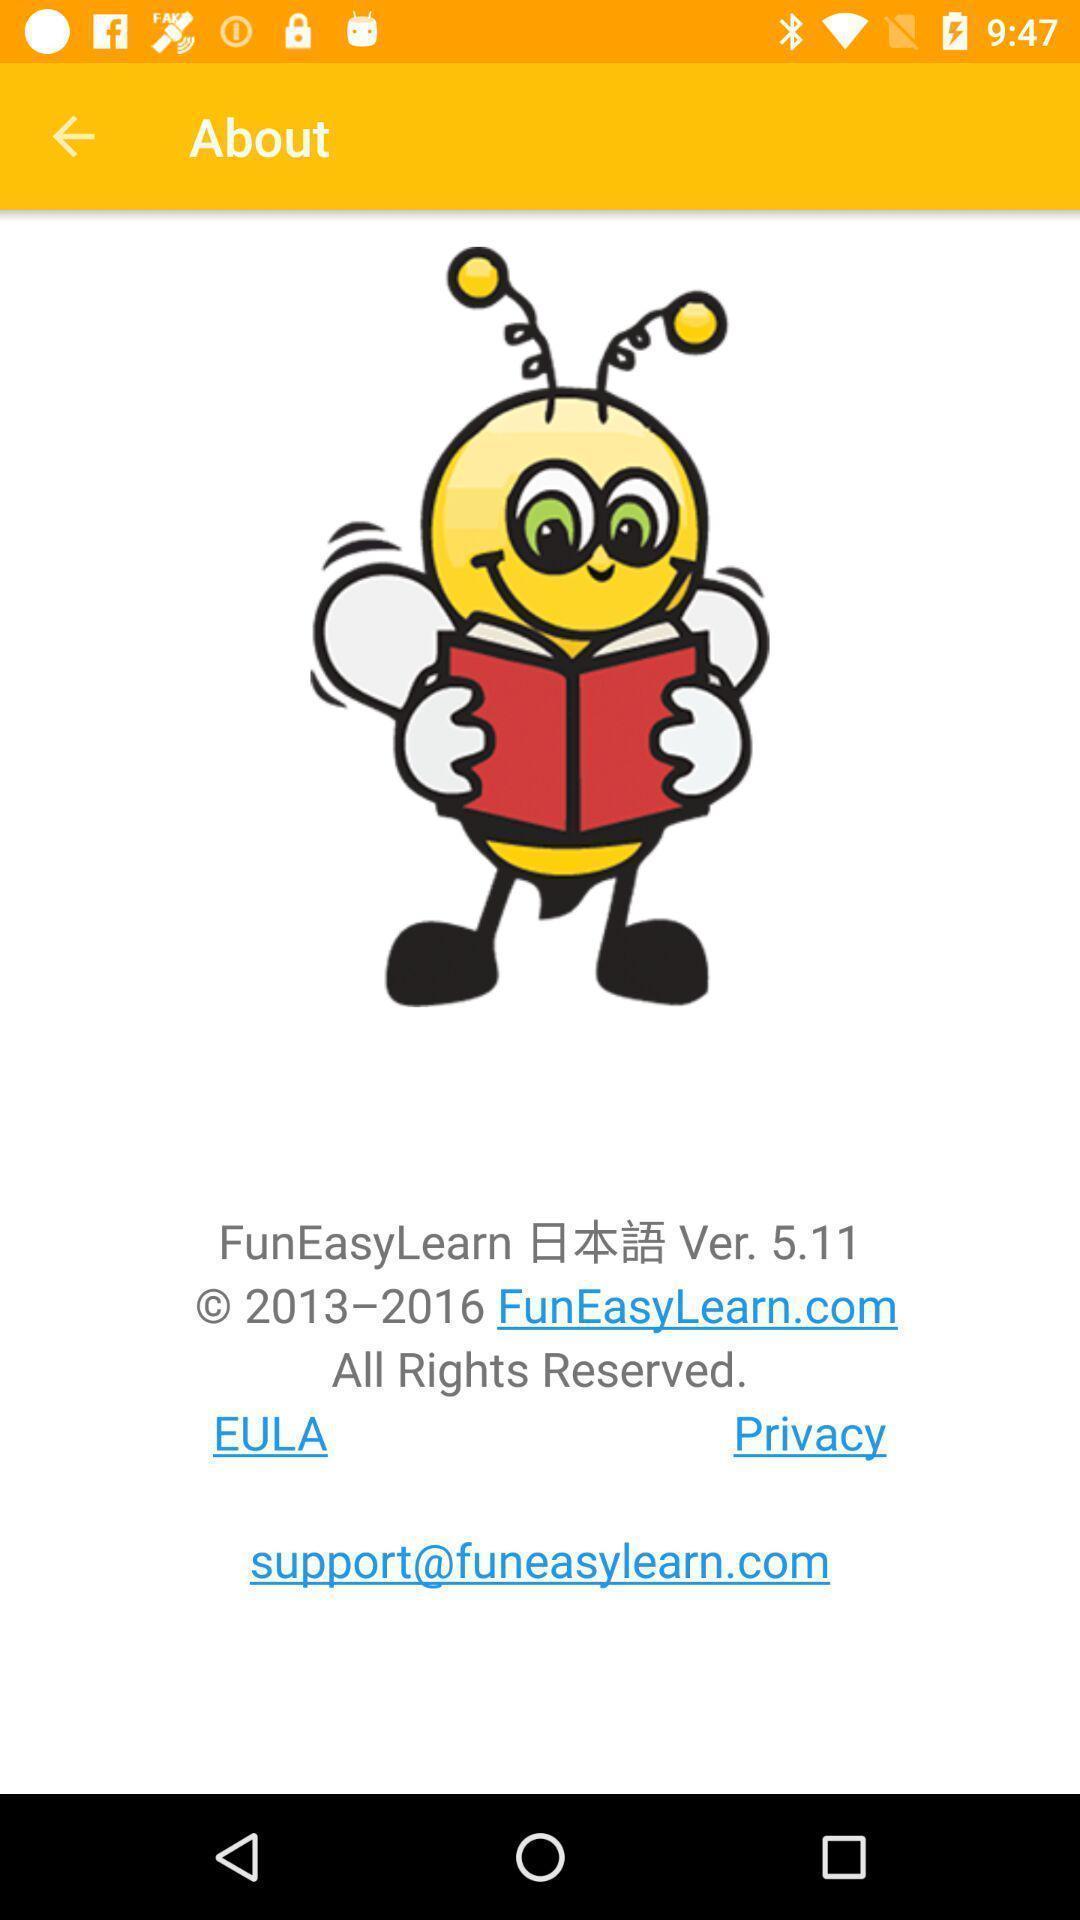Tell me about the visual elements in this screen capture. Screen showing about. 